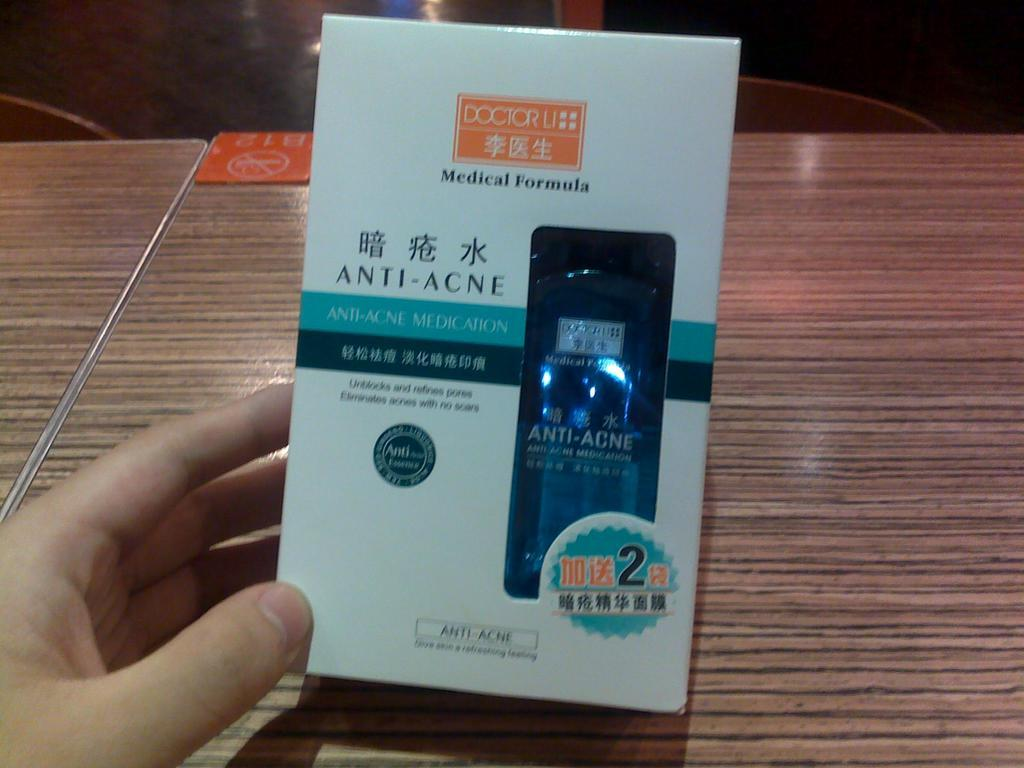Provide a one-sentence caption for the provided image. A hand is holding a box of anti-acne medicine. 